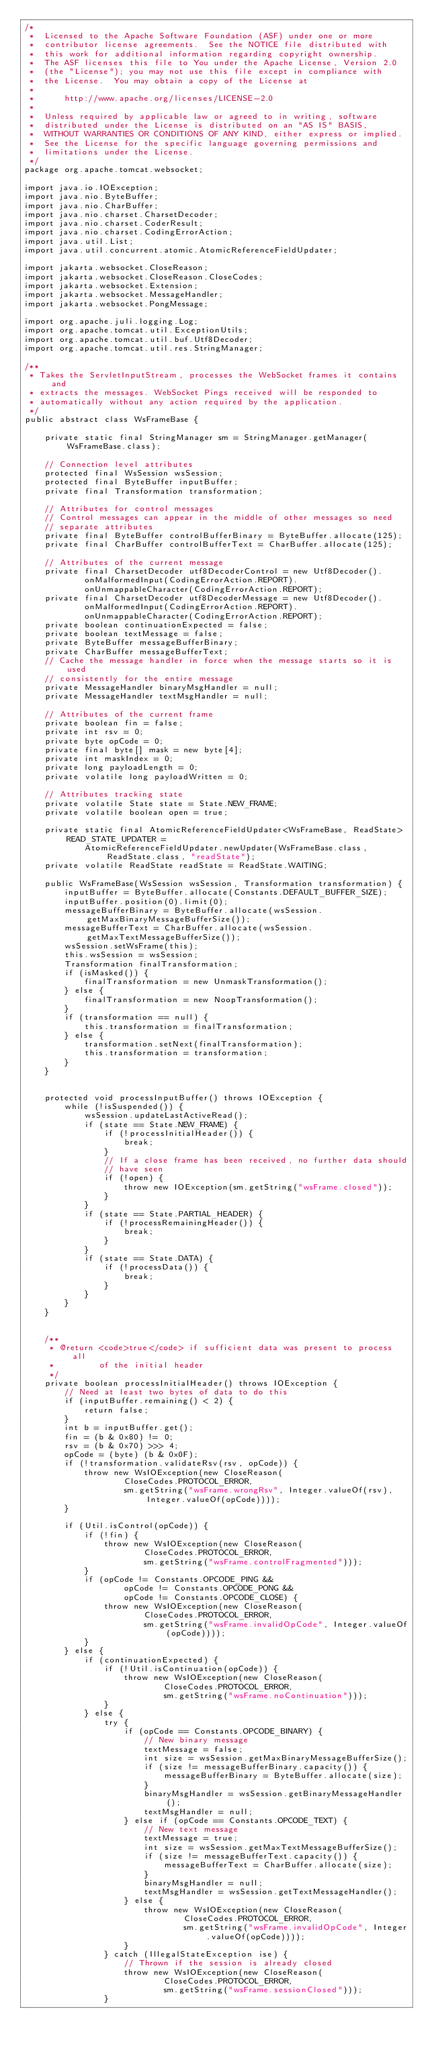Convert code to text. <code><loc_0><loc_0><loc_500><loc_500><_Java_>/*
 *  Licensed to the Apache Software Foundation (ASF) under one or more
 *  contributor license agreements.  See the NOTICE file distributed with
 *  this work for additional information regarding copyright ownership.
 *  The ASF licenses this file to You under the Apache License, Version 2.0
 *  (the "License"); you may not use this file except in compliance with
 *  the License.  You may obtain a copy of the License at
 *
 *      http://www.apache.org/licenses/LICENSE-2.0
 *
 *  Unless required by applicable law or agreed to in writing, software
 *  distributed under the License is distributed on an "AS IS" BASIS,
 *  WITHOUT WARRANTIES OR CONDITIONS OF ANY KIND, either express or implied.
 *  See the License for the specific language governing permissions and
 *  limitations under the License.
 */
package org.apache.tomcat.websocket;

import java.io.IOException;
import java.nio.ByteBuffer;
import java.nio.CharBuffer;
import java.nio.charset.CharsetDecoder;
import java.nio.charset.CoderResult;
import java.nio.charset.CodingErrorAction;
import java.util.List;
import java.util.concurrent.atomic.AtomicReferenceFieldUpdater;

import jakarta.websocket.CloseReason;
import jakarta.websocket.CloseReason.CloseCodes;
import jakarta.websocket.Extension;
import jakarta.websocket.MessageHandler;
import jakarta.websocket.PongMessage;

import org.apache.juli.logging.Log;
import org.apache.tomcat.util.ExceptionUtils;
import org.apache.tomcat.util.buf.Utf8Decoder;
import org.apache.tomcat.util.res.StringManager;

/**
 * Takes the ServletInputStream, processes the WebSocket frames it contains and
 * extracts the messages. WebSocket Pings received will be responded to
 * automatically without any action required by the application.
 */
public abstract class WsFrameBase {

    private static final StringManager sm = StringManager.getManager(WsFrameBase.class);

    // Connection level attributes
    protected final WsSession wsSession;
    protected final ByteBuffer inputBuffer;
    private final Transformation transformation;

    // Attributes for control messages
    // Control messages can appear in the middle of other messages so need
    // separate attributes
    private final ByteBuffer controlBufferBinary = ByteBuffer.allocate(125);
    private final CharBuffer controlBufferText = CharBuffer.allocate(125);

    // Attributes of the current message
    private final CharsetDecoder utf8DecoderControl = new Utf8Decoder().
            onMalformedInput(CodingErrorAction.REPORT).
            onUnmappableCharacter(CodingErrorAction.REPORT);
    private final CharsetDecoder utf8DecoderMessage = new Utf8Decoder().
            onMalformedInput(CodingErrorAction.REPORT).
            onUnmappableCharacter(CodingErrorAction.REPORT);
    private boolean continuationExpected = false;
    private boolean textMessage = false;
    private ByteBuffer messageBufferBinary;
    private CharBuffer messageBufferText;
    // Cache the message handler in force when the message starts so it is used
    // consistently for the entire message
    private MessageHandler binaryMsgHandler = null;
    private MessageHandler textMsgHandler = null;

    // Attributes of the current frame
    private boolean fin = false;
    private int rsv = 0;
    private byte opCode = 0;
    private final byte[] mask = new byte[4];
    private int maskIndex = 0;
    private long payloadLength = 0;
    private volatile long payloadWritten = 0;

    // Attributes tracking state
    private volatile State state = State.NEW_FRAME;
    private volatile boolean open = true;

    private static final AtomicReferenceFieldUpdater<WsFrameBase, ReadState> READ_STATE_UPDATER =
            AtomicReferenceFieldUpdater.newUpdater(WsFrameBase.class, ReadState.class, "readState");
    private volatile ReadState readState = ReadState.WAITING;

    public WsFrameBase(WsSession wsSession, Transformation transformation) {
        inputBuffer = ByteBuffer.allocate(Constants.DEFAULT_BUFFER_SIZE);
        inputBuffer.position(0).limit(0);
        messageBufferBinary = ByteBuffer.allocate(wsSession.getMaxBinaryMessageBufferSize());
        messageBufferText = CharBuffer.allocate(wsSession.getMaxTextMessageBufferSize());
        wsSession.setWsFrame(this);
        this.wsSession = wsSession;
        Transformation finalTransformation;
        if (isMasked()) {
            finalTransformation = new UnmaskTransformation();
        } else {
            finalTransformation = new NoopTransformation();
        }
        if (transformation == null) {
            this.transformation = finalTransformation;
        } else {
            transformation.setNext(finalTransformation);
            this.transformation = transformation;
        }
    }


    protected void processInputBuffer() throws IOException {
        while (!isSuspended()) {
            wsSession.updateLastActiveRead();
            if (state == State.NEW_FRAME) {
                if (!processInitialHeader()) {
                    break;
                }
                // If a close frame has been received, no further data should
                // have seen
                if (!open) {
                    throw new IOException(sm.getString("wsFrame.closed"));
                }
            }
            if (state == State.PARTIAL_HEADER) {
                if (!processRemainingHeader()) {
                    break;
                }
            }
            if (state == State.DATA) {
                if (!processData()) {
                    break;
                }
            }
        }
    }


    /**
     * @return <code>true</code> if sufficient data was present to process all
     *         of the initial header
     */
    private boolean processInitialHeader() throws IOException {
        // Need at least two bytes of data to do this
        if (inputBuffer.remaining() < 2) {
            return false;
        }
        int b = inputBuffer.get();
        fin = (b & 0x80) != 0;
        rsv = (b & 0x70) >>> 4;
        opCode = (byte) (b & 0x0F);
        if (!transformation.validateRsv(rsv, opCode)) {
            throw new WsIOException(new CloseReason(
                    CloseCodes.PROTOCOL_ERROR,
                    sm.getString("wsFrame.wrongRsv", Integer.valueOf(rsv), Integer.valueOf(opCode))));
        }

        if (Util.isControl(opCode)) {
            if (!fin) {
                throw new WsIOException(new CloseReason(
                        CloseCodes.PROTOCOL_ERROR,
                        sm.getString("wsFrame.controlFragmented")));
            }
            if (opCode != Constants.OPCODE_PING &&
                    opCode != Constants.OPCODE_PONG &&
                    opCode != Constants.OPCODE_CLOSE) {
                throw new WsIOException(new CloseReason(
                        CloseCodes.PROTOCOL_ERROR,
                        sm.getString("wsFrame.invalidOpCode", Integer.valueOf(opCode))));
            }
        } else {
            if (continuationExpected) {
                if (!Util.isContinuation(opCode)) {
                    throw new WsIOException(new CloseReason(
                            CloseCodes.PROTOCOL_ERROR,
                            sm.getString("wsFrame.noContinuation")));
                }
            } else {
                try {
                    if (opCode == Constants.OPCODE_BINARY) {
                        // New binary message
                        textMessage = false;
                        int size = wsSession.getMaxBinaryMessageBufferSize();
                        if (size != messageBufferBinary.capacity()) {
                            messageBufferBinary = ByteBuffer.allocate(size);
                        }
                        binaryMsgHandler = wsSession.getBinaryMessageHandler();
                        textMsgHandler = null;
                    } else if (opCode == Constants.OPCODE_TEXT) {
                        // New text message
                        textMessage = true;
                        int size = wsSession.getMaxTextMessageBufferSize();
                        if (size != messageBufferText.capacity()) {
                            messageBufferText = CharBuffer.allocate(size);
                        }
                        binaryMsgHandler = null;
                        textMsgHandler = wsSession.getTextMessageHandler();
                    } else {
                        throw new WsIOException(new CloseReason(
                                CloseCodes.PROTOCOL_ERROR,
                                sm.getString("wsFrame.invalidOpCode", Integer.valueOf(opCode))));
                    }
                } catch (IllegalStateException ise) {
                    // Thrown if the session is already closed
                    throw new WsIOException(new CloseReason(
                            CloseCodes.PROTOCOL_ERROR,
                            sm.getString("wsFrame.sessionClosed")));
                }</code> 